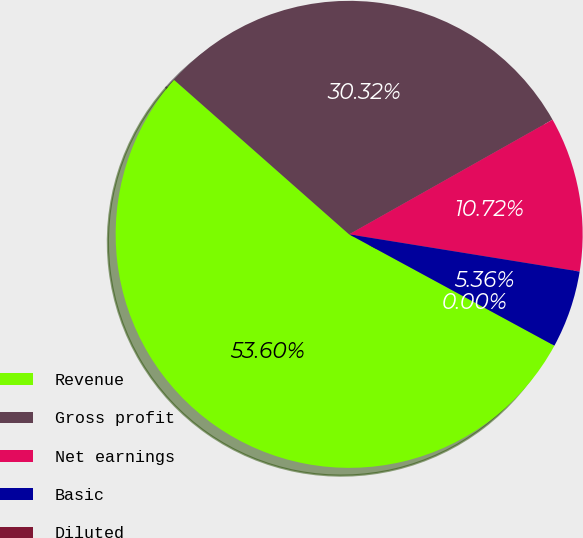Convert chart. <chart><loc_0><loc_0><loc_500><loc_500><pie_chart><fcel>Revenue<fcel>Gross profit<fcel>Net earnings<fcel>Basic<fcel>Diluted<nl><fcel>53.6%<fcel>30.32%<fcel>10.72%<fcel>5.36%<fcel>0.0%<nl></chart> 